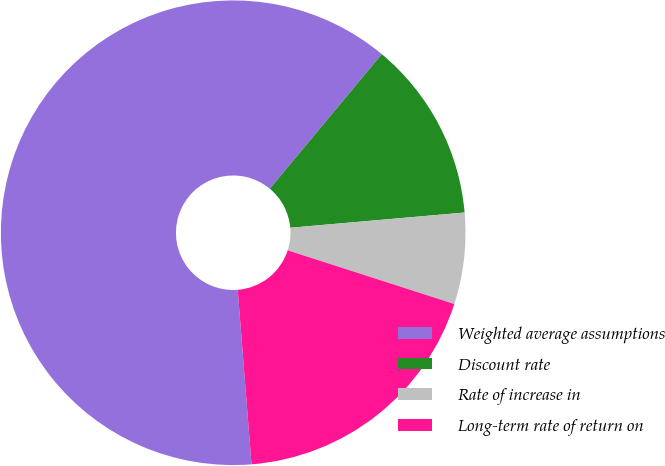<chart> <loc_0><loc_0><loc_500><loc_500><pie_chart><fcel>Weighted average assumptions<fcel>Discount rate<fcel>Rate of increase in<fcel>Long-term rate of return on<nl><fcel>62.3%<fcel>12.57%<fcel>6.35%<fcel>18.78%<nl></chart> 